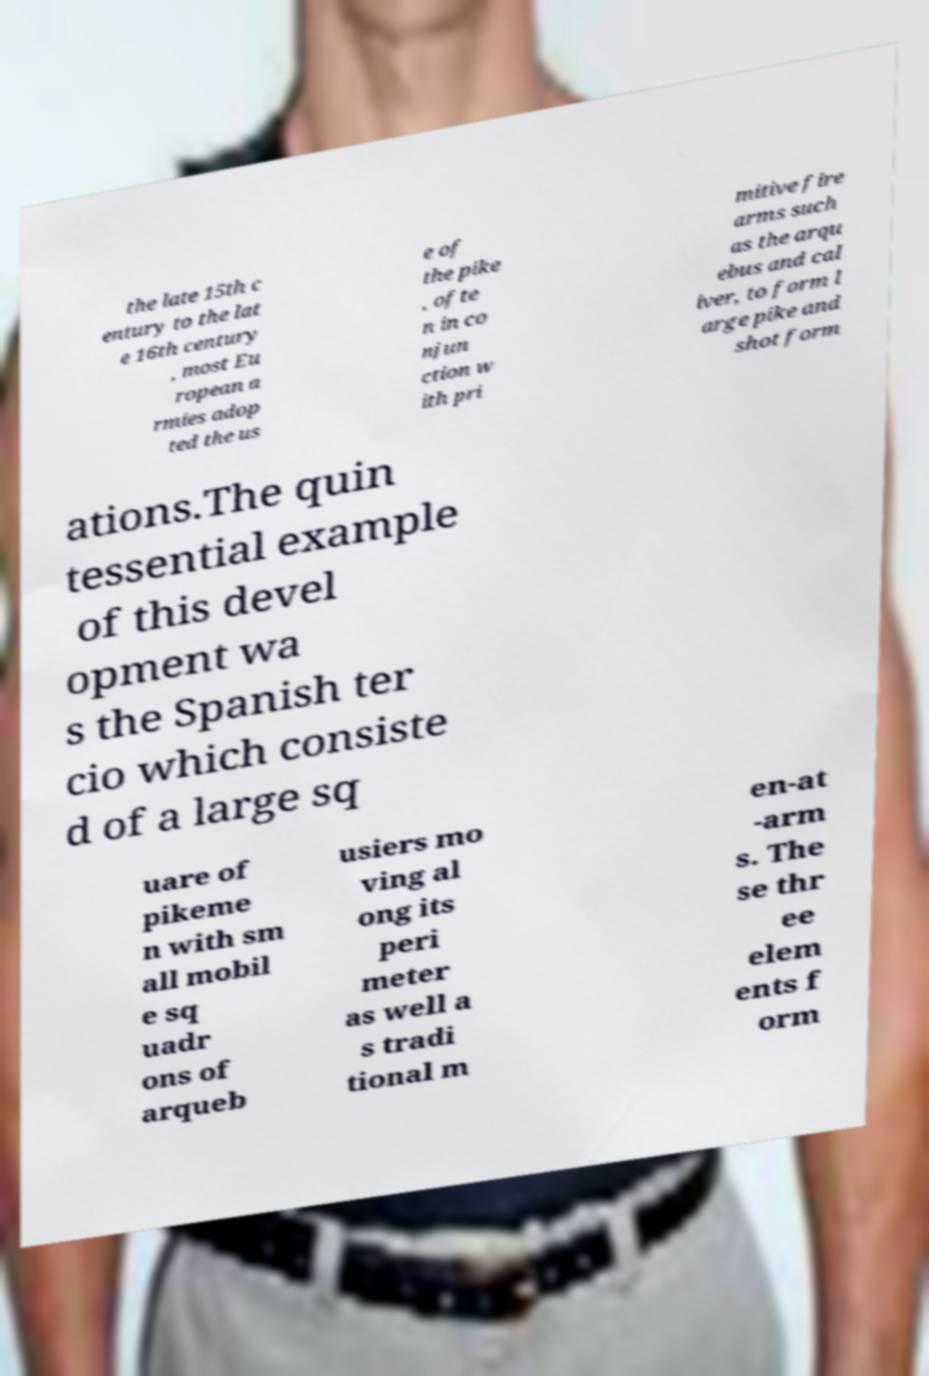Could you extract and type out the text from this image? the late 15th c entury to the lat e 16th century , most Eu ropean a rmies adop ted the us e of the pike , ofte n in co njun ction w ith pri mitive fire arms such as the arqu ebus and cal iver, to form l arge pike and shot form ations.The quin tessential example of this devel opment wa s the Spanish ter cio which consiste d of a large sq uare of pikeme n with sm all mobil e sq uadr ons of arqueb usiers mo ving al ong its peri meter as well a s tradi tional m en-at -arm s. The se thr ee elem ents f orm 